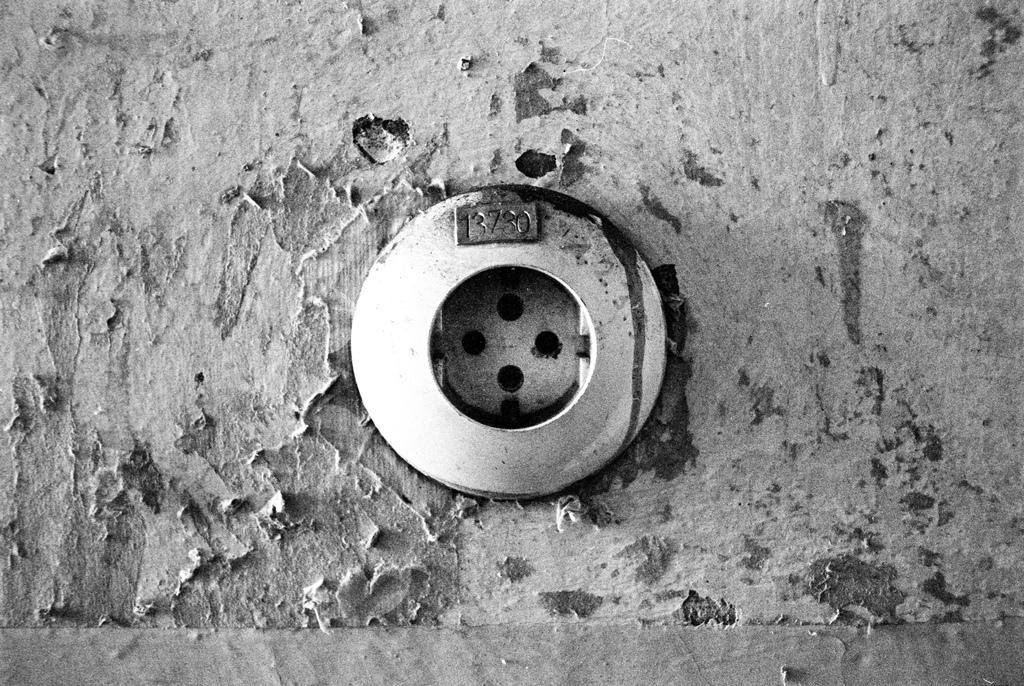<image>
Relay a brief, clear account of the picture shown. a black and white photo of what looks like a drain with the number 13730 written above it 